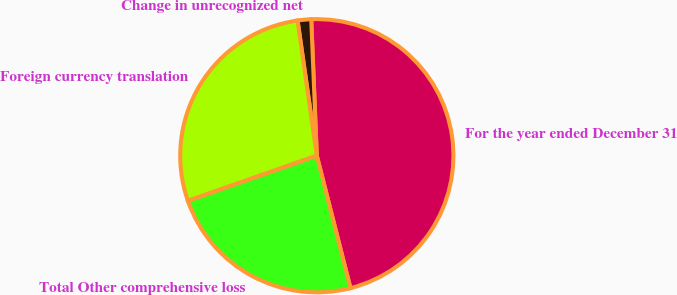Convert chart. <chart><loc_0><loc_0><loc_500><loc_500><pie_chart><fcel>For the year ended December 31<fcel>Change in unrecognized net<fcel>Foreign currency translation<fcel>Total Other comprehensive loss<nl><fcel>46.69%<fcel>1.6%<fcel>28.11%<fcel>23.6%<nl></chart> 